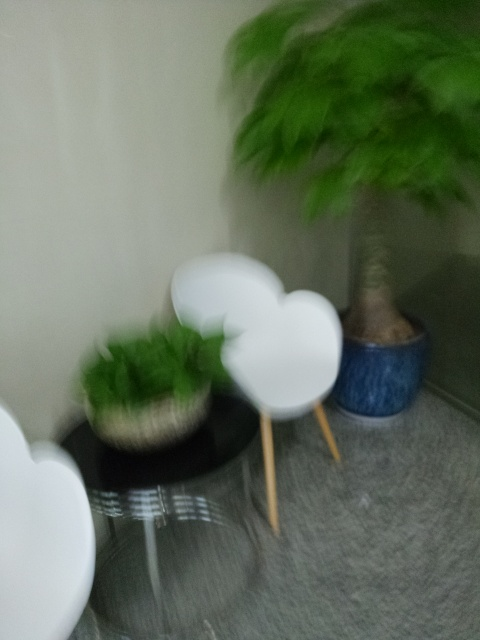What type of furniture is shown in the image? The image displays modern-style furniture, including what appears to be sleek, white chairs and a round side table. However, due to the blurriness of the image, the specific details are unclear. 